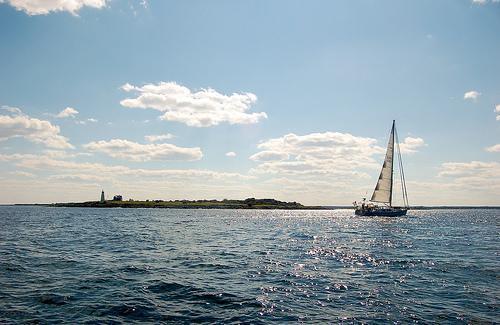How many boats are there?
Give a very brief answer. 1. 